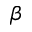Convert formula to latex. <formula><loc_0><loc_0><loc_500><loc_500>\beta</formula> 